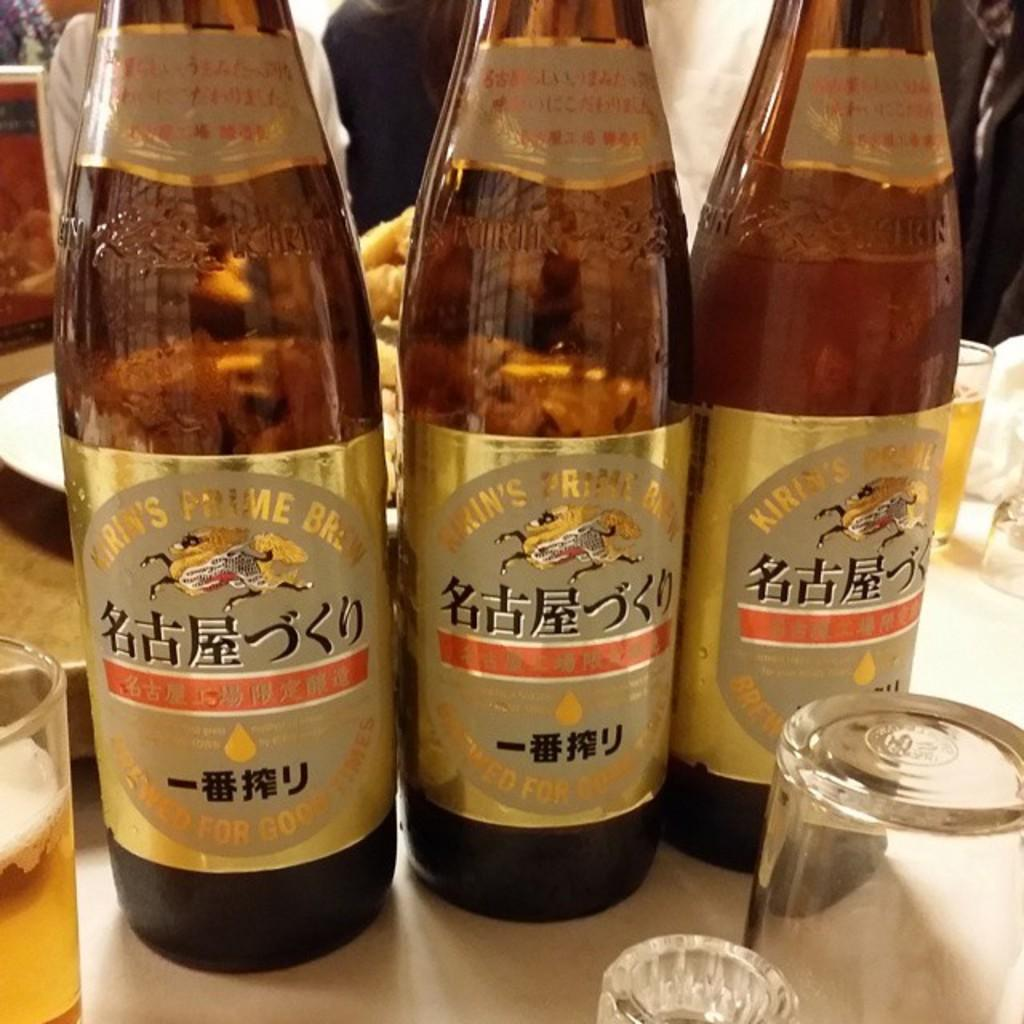What type of containers can be seen in the image? There are bottles and glasses in the image. Can you describe the contents of these containers? The contents of the containers are not visible in the image. Can you see a shoe in the image? No, there is no shoe present in the image. Is there a giraffe in the image? No, there is no giraffe present in the image. 